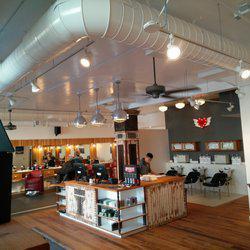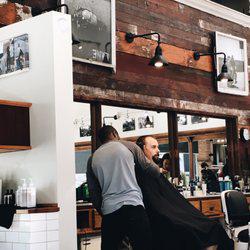The first image is the image on the left, the second image is the image on the right. Evaluate the accuracy of this statement regarding the images: "In one image a single barber is working with a customer, while a person stands at a store counter in the second image.". Is it true? Answer yes or no. Yes. The first image is the image on the left, the second image is the image on the right. For the images shown, is this caption "A camera-facing man is standing by a camera-facing empty black barber chair with white arms, in one image." true? Answer yes or no. No. 